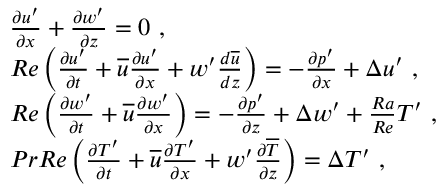<formula> <loc_0><loc_0><loc_500><loc_500>\begin{array} { r l } & { \frac { \partial { u ^ { \prime } } } { \partial x } + \frac { \partial { w ^ { \prime } } } { \partial z } = 0 , } \\ & { R e \left ( \frac { \partial { u ^ { \prime } } } { \partial t } + \overline { u } \frac { \partial { u ^ { \prime } } } { \partial x } + { w ^ { \prime } } \frac { d \overline { u } } { d z } \right ) = - \frac { \partial { p ^ { \prime } } } { \partial x } + \Delta { u ^ { \prime } } , } \\ & { R e \left ( \frac { \partial { w ^ { \prime } } } { \partial t } + \overline { u } \frac { \partial { w ^ { \prime } } } { \partial x } \right ) = - \frac { \partial { p ^ { \prime } } } { \partial z } + \Delta { w ^ { \prime } } + \frac { R a } { R e } { T ^ { \prime } } , } \\ & { P r R e \left ( \frac { \partial { T ^ { \prime } } } { \partial t } + \overline { u } \frac { \partial { T ^ { \prime } } } { \partial x } + { w ^ { \prime } } \frac { \partial \overline { T } } { \partial z } \right ) = \Delta { T ^ { \prime } } , } \end{array}</formula> 